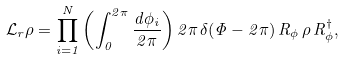<formula> <loc_0><loc_0><loc_500><loc_500>\mathcal { L } _ { r } \rho = \prod _ { i = 1 } ^ { N } \left ( \int ^ { 2 \pi } _ { 0 } \frac { d \phi _ { i } } { 2 \pi } \right ) 2 \pi \, \delta ( \Phi - 2 \pi ) \, R _ { \phi } \, \rho \, R _ { \phi } ^ { \dagger } ,</formula> 